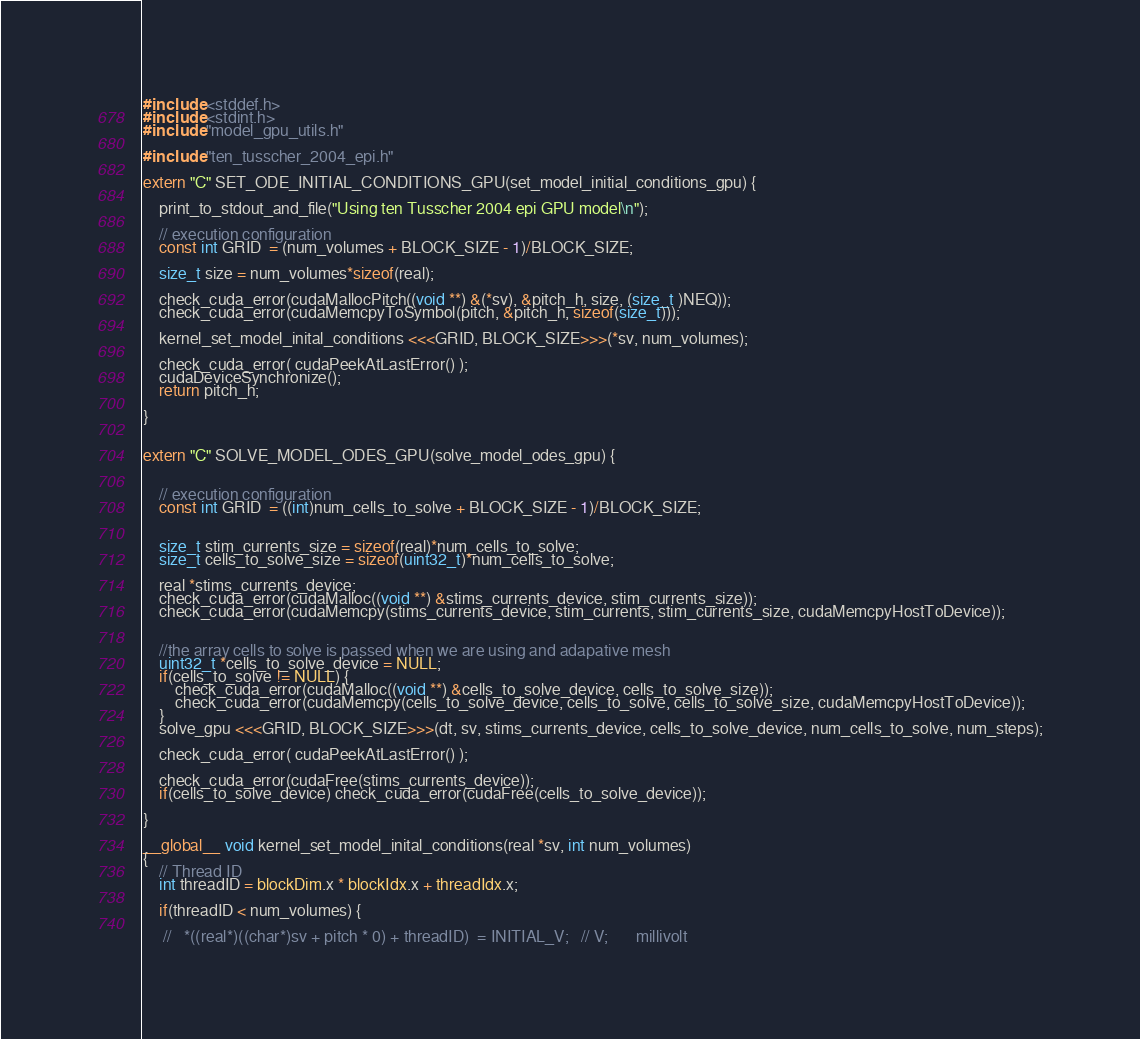<code> <loc_0><loc_0><loc_500><loc_500><_Cuda_>#include <stddef.h>
#include <stdint.h>
#include "model_gpu_utils.h"

#include "ten_tusscher_2004_epi.h"

extern "C" SET_ODE_INITIAL_CONDITIONS_GPU(set_model_initial_conditions_gpu) {

    print_to_stdout_and_file("Using ten Tusscher 2004 epi GPU model\n");

    // execution configuration
    const int GRID  = (num_volumes + BLOCK_SIZE - 1)/BLOCK_SIZE;

    size_t size = num_volumes*sizeof(real);

    check_cuda_error(cudaMallocPitch((void **) &(*sv), &pitch_h, size, (size_t )NEQ));
    check_cuda_error(cudaMemcpyToSymbol(pitch, &pitch_h, sizeof(size_t)));

    kernel_set_model_inital_conditions <<<GRID, BLOCK_SIZE>>>(*sv, num_volumes);

    check_cuda_error( cudaPeekAtLastError() );
    cudaDeviceSynchronize();
    return pitch_h;

}


extern "C" SOLVE_MODEL_ODES_GPU(solve_model_odes_gpu) {


    // execution configuration
    const int GRID  = ((int)num_cells_to_solve + BLOCK_SIZE - 1)/BLOCK_SIZE;


    size_t stim_currents_size = sizeof(real)*num_cells_to_solve;
    size_t cells_to_solve_size = sizeof(uint32_t)*num_cells_to_solve;

    real *stims_currents_device;
    check_cuda_error(cudaMalloc((void **) &stims_currents_device, stim_currents_size));
    check_cuda_error(cudaMemcpy(stims_currents_device, stim_currents, stim_currents_size, cudaMemcpyHostToDevice));


    //the array cells to solve is passed when we are using and adapative mesh
    uint32_t *cells_to_solve_device = NULL;
    if(cells_to_solve != NULL) {
        check_cuda_error(cudaMalloc((void **) &cells_to_solve_device, cells_to_solve_size));
        check_cuda_error(cudaMemcpy(cells_to_solve_device, cells_to_solve, cells_to_solve_size, cudaMemcpyHostToDevice));
    }
    solve_gpu <<<GRID, BLOCK_SIZE>>>(dt, sv, stims_currents_device, cells_to_solve_device, num_cells_to_solve, num_steps);

    check_cuda_error( cudaPeekAtLastError() );

    check_cuda_error(cudaFree(stims_currents_device));
    if(cells_to_solve_device) check_cuda_error(cudaFree(cells_to_solve_device));

}

__global__ void kernel_set_model_inital_conditions(real *sv, int num_volumes)
{
    // Thread ID
    int threadID = blockDim.x * blockIdx.x + threadIdx.x;

    if(threadID < num_volumes) {

     //   *((real*)((char*)sv + pitch * 0) + threadID)  = INITIAL_V;   // V;       millivolt</code> 